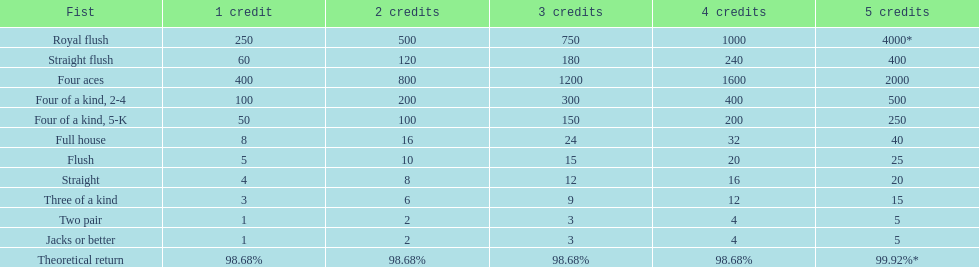Can you give me this table as a dict? {'header': ['Fist', '1 credit', '2 credits', '3 credits', '4 credits', '5 credits'], 'rows': [['Royal flush', '250', '500', '750', '1000', '4000*'], ['Straight flush', '60', '120', '180', '240', '400'], ['Four aces', '400', '800', '1200', '1600', '2000'], ['Four of a kind, 2-4', '100', '200', '300', '400', '500'], ['Four of a kind, 5-K', '50', '100', '150', '200', '250'], ['Full house', '8', '16', '24', '32', '40'], ['Flush', '5', '10', '15', '20', '25'], ['Straight', '4', '8', '12', '16', '20'], ['Three of a kind', '3', '6', '9', '12', '15'], ['Two pair', '1', '2', '3', '4', '5'], ['Jacks or better', '1', '2', '3', '4', '5'], ['Theoretical return', '98.68%', '98.68%', '98.68%', '98.68%', '99.92%*']]} What is the difference of payout on 3 credits, between a straight flush and royal flush? 570. 